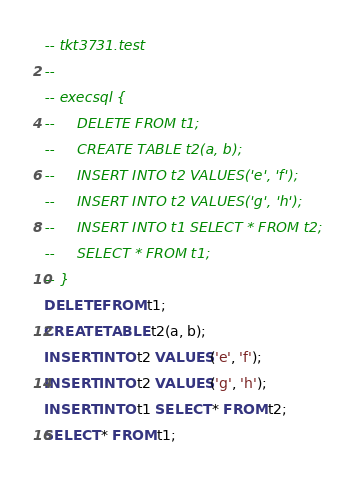<code> <loc_0><loc_0><loc_500><loc_500><_SQL_>-- tkt3731.test
-- 
-- execsql {
--     DELETE FROM t1;
--     CREATE TABLE t2(a, b);
--     INSERT INTO t2 VALUES('e', 'f');
--     INSERT INTO t2 VALUES('g', 'h');
--     INSERT INTO t1 SELECT * FROM t2;
--     SELECT * FROM t1;
-- }
DELETE FROM t1;
CREATE TABLE t2(a, b);
INSERT INTO t2 VALUES('e', 'f');
INSERT INTO t2 VALUES('g', 'h');
INSERT INTO t1 SELECT * FROM t2;
SELECT * FROM t1;</code> 